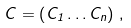<formula> <loc_0><loc_0><loc_500><loc_500>C = \left ( C _ { 1 } \dots C _ { n } \right ) \, ,</formula> 